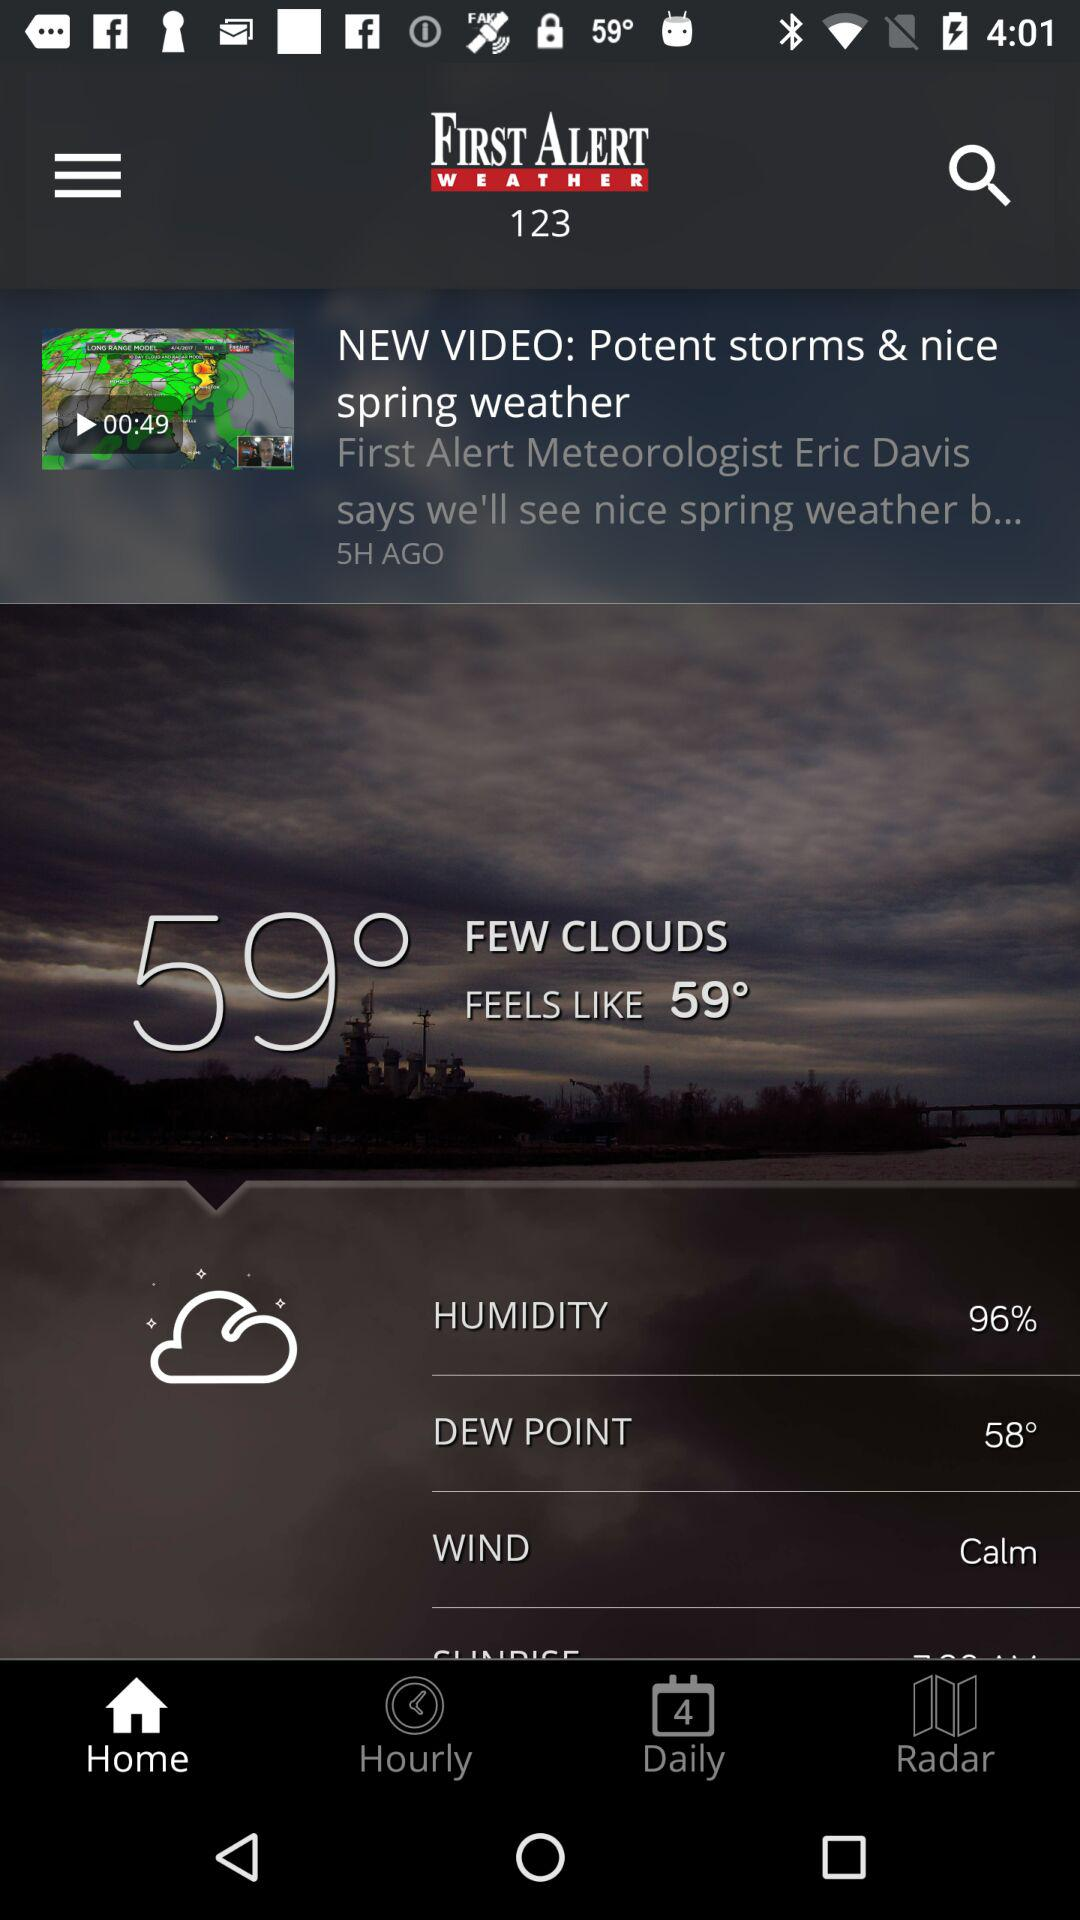What is the difference between the current temperature and the feels like temperature?
Answer the question using a single word or phrase. 0° 